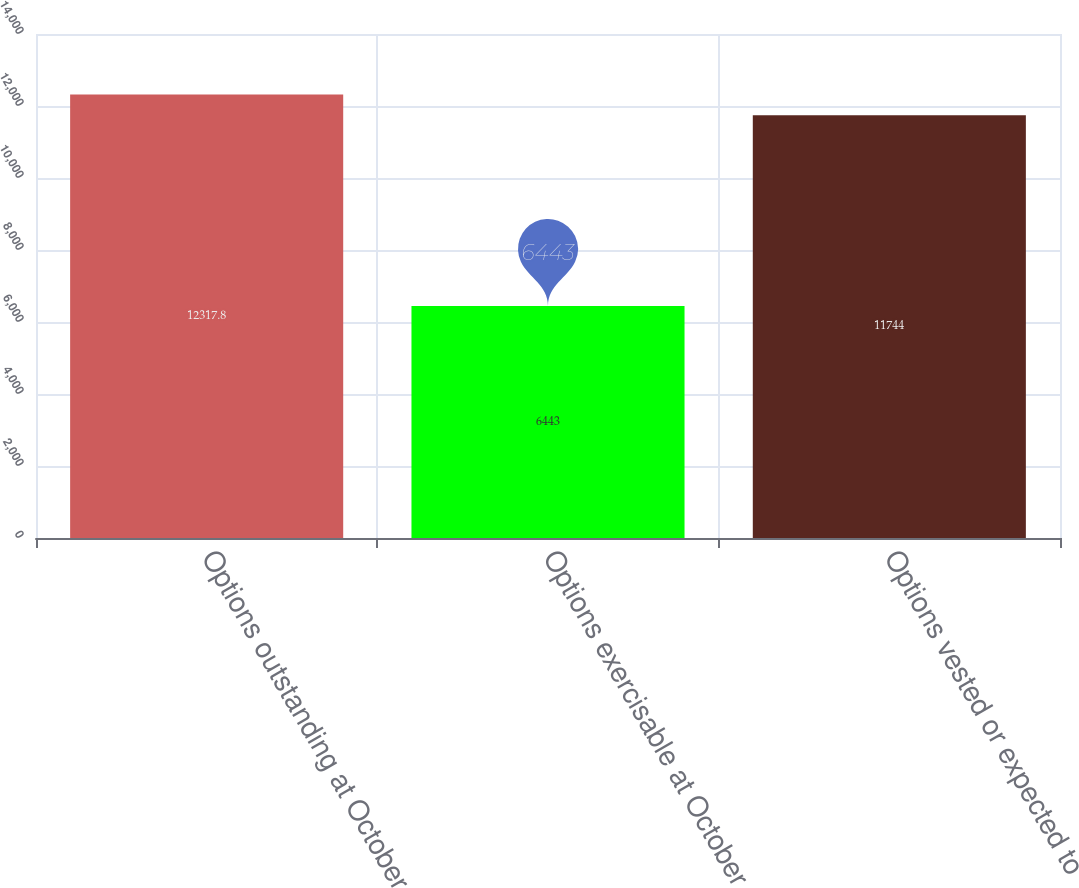Convert chart to OTSL. <chart><loc_0><loc_0><loc_500><loc_500><bar_chart><fcel>Options outstanding at October<fcel>Options exercisable at October<fcel>Options vested or expected to<nl><fcel>12317.8<fcel>6443<fcel>11744<nl></chart> 